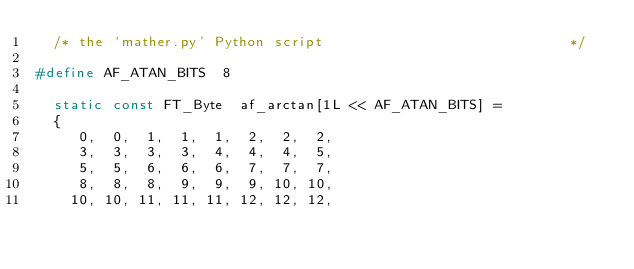Convert code to text. <code><loc_0><loc_0><loc_500><loc_500><_C_>  /* the `mather.py' Python script                             */

#define AF_ATAN_BITS  8

  static const FT_Byte  af_arctan[1L << AF_ATAN_BITS] =
  {
     0,  0,  1,  1,  1,  2,  2,  2,
     3,  3,  3,  3,  4,  4,  4,  5,
     5,  5,  6,  6,  6,  7,  7,  7,
     8,  8,  8,  9,  9,  9, 10, 10,
    10, 10, 11, 11, 11, 12, 12, 12,</code> 